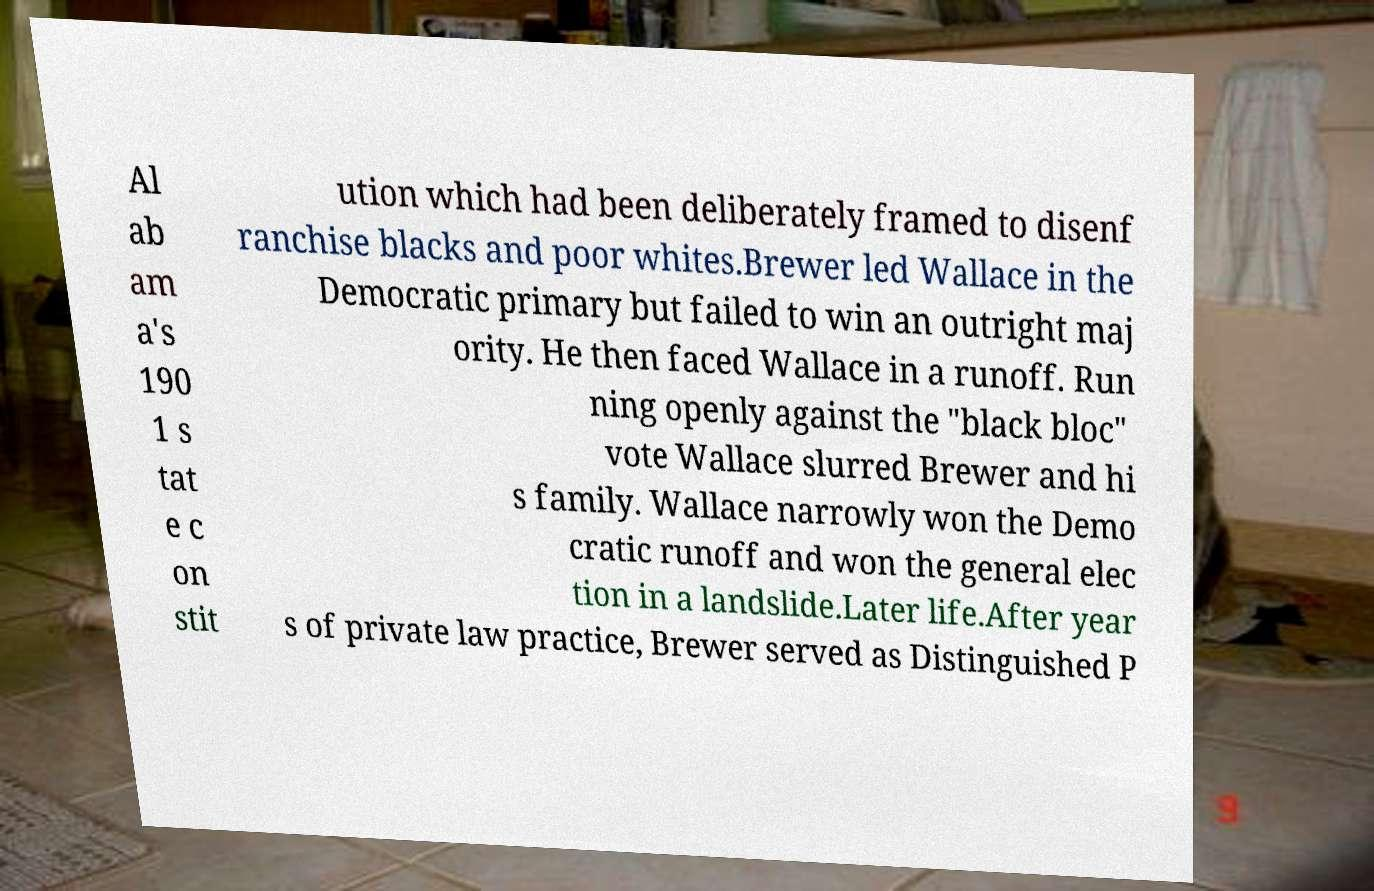Please read and relay the text visible in this image. What does it say? Al ab am a's 190 1 s tat e c on stit ution which had been deliberately framed to disenf ranchise blacks and poor whites.Brewer led Wallace in the Democratic primary but failed to win an outright maj ority. He then faced Wallace in a runoff. Run ning openly against the "black bloc" vote Wallace slurred Brewer and hi s family. Wallace narrowly won the Demo cratic runoff and won the general elec tion in a landslide.Later life.After year s of private law practice, Brewer served as Distinguished P 